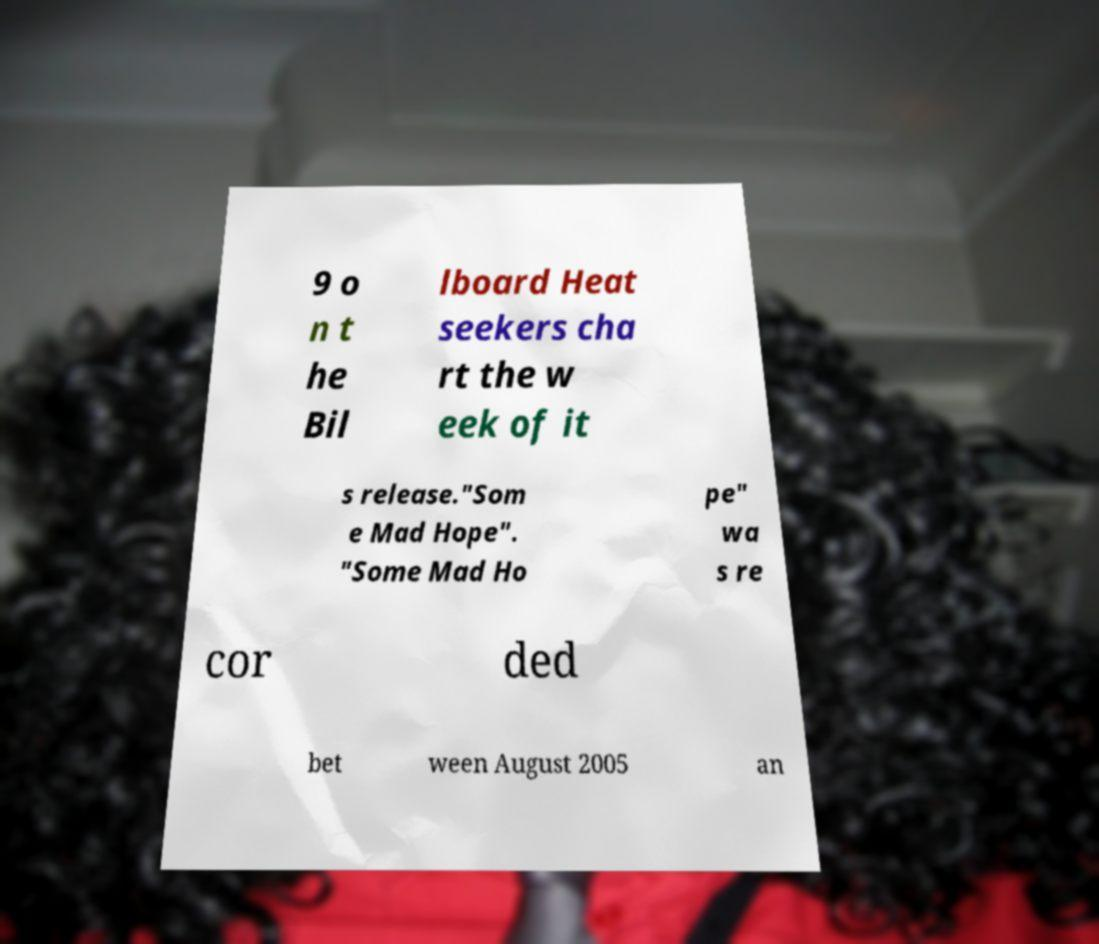Could you assist in decoding the text presented in this image and type it out clearly? 9 o n t he Bil lboard Heat seekers cha rt the w eek of it s release."Som e Mad Hope". "Some Mad Ho pe" wa s re cor ded bet ween August 2005 an 